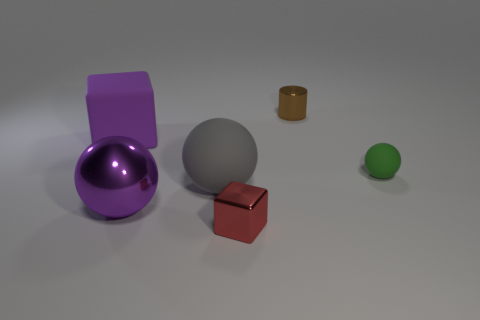What number of other objects are there of the same color as the big shiny ball?
Your answer should be very brief. 1. Are the tiny green thing and the tiny brown cylinder made of the same material?
Keep it short and to the point. No. There is another big object that is made of the same material as the red object; what is its shape?
Give a very brief answer. Sphere. There is a small thing that is both behind the big gray matte object and on the left side of the green sphere; what is its material?
Your answer should be very brief. Metal. What is the size of the ball on the right side of the brown shiny thing that is left of the tiny thing that is right of the brown metallic cylinder?
Offer a terse response. Small. Do the tiny green thing and the metallic object that is left of the tiny red shiny cube have the same shape?
Give a very brief answer. Yes. How many tiny things are behind the red block and left of the small green matte sphere?
Your answer should be very brief. 1. There is a cube that is on the left side of the red cube; is it the same color as the large metal ball that is on the left side of the brown cylinder?
Give a very brief answer. Yes. There is a object to the right of the cylinder that is to the right of the block behind the small green rubber thing; what color is it?
Offer a terse response. Green. Are there any brown cylinders that are to the right of the large rubber thing in front of the tiny rubber object?
Offer a terse response. Yes. 